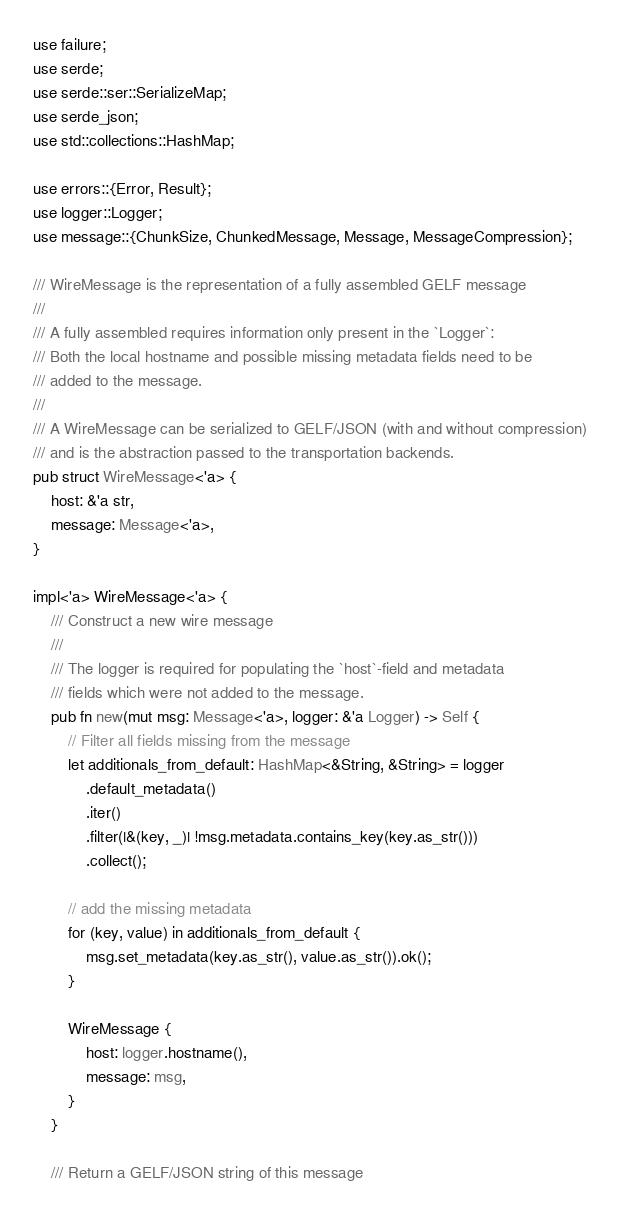<code> <loc_0><loc_0><loc_500><loc_500><_Rust_>use failure;
use serde;
use serde::ser::SerializeMap;
use serde_json;
use std::collections::HashMap;

use errors::{Error, Result};
use logger::Logger;
use message::{ChunkSize, ChunkedMessage, Message, MessageCompression};

/// WireMessage is the representation of a fully assembled GELF message
///
/// A fully assembled requires information only present in the `Logger`:
/// Both the local hostname and possible missing metadata fields need to be
/// added to the message.
///
/// A WireMessage can be serialized to GELF/JSON (with and without compression)
/// and is the abstraction passed to the transportation backends.
pub struct WireMessage<'a> {
    host: &'a str,
    message: Message<'a>,
}

impl<'a> WireMessage<'a> {
    /// Construct a new wire message
    ///
    /// The logger is required for populating the `host`-field and metadata
    /// fields which were not added to the message.
    pub fn new(mut msg: Message<'a>, logger: &'a Logger) -> Self {
        // Filter all fields missing from the message
        let additionals_from_default: HashMap<&String, &String> = logger
            .default_metadata()
            .iter()
            .filter(|&(key, _)| !msg.metadata.contains_key(key.as_str()))
            .collect();

        // add the missing metadata
        for (key, value) in additionals_from_default {
            msg.set_metadata(key.as_str(), value.as_str()).ok();
        }

        WireMessage {
            host: logger.hostname(),
            message: msg,
        }
    }

    /// Return a GELF/JSON string of this message</code> 